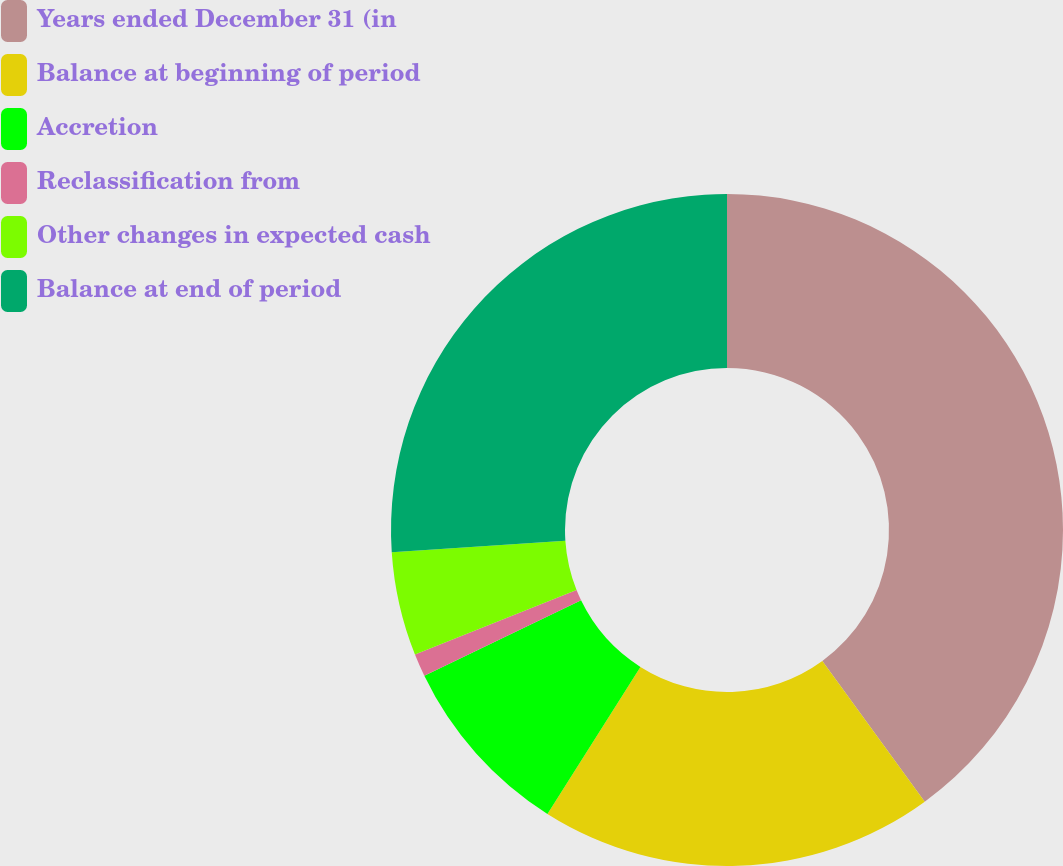Convert chart. <chart><loc_0><loc_0><loc_500><loc_500><pie_chart><fcel>Years ended December 31 (in<fcel>Balance at beginning of period<fcel>Accretion<fcel>Reclassification from<fcel>Other changes in expected cash<fcel>Balance at end of period<nl><fcel>39.99%<fcel>18.99%<fcel>8.88%<fcel>1.1%<fcel>4.99%<fcel>26.06%<nl></chart> 